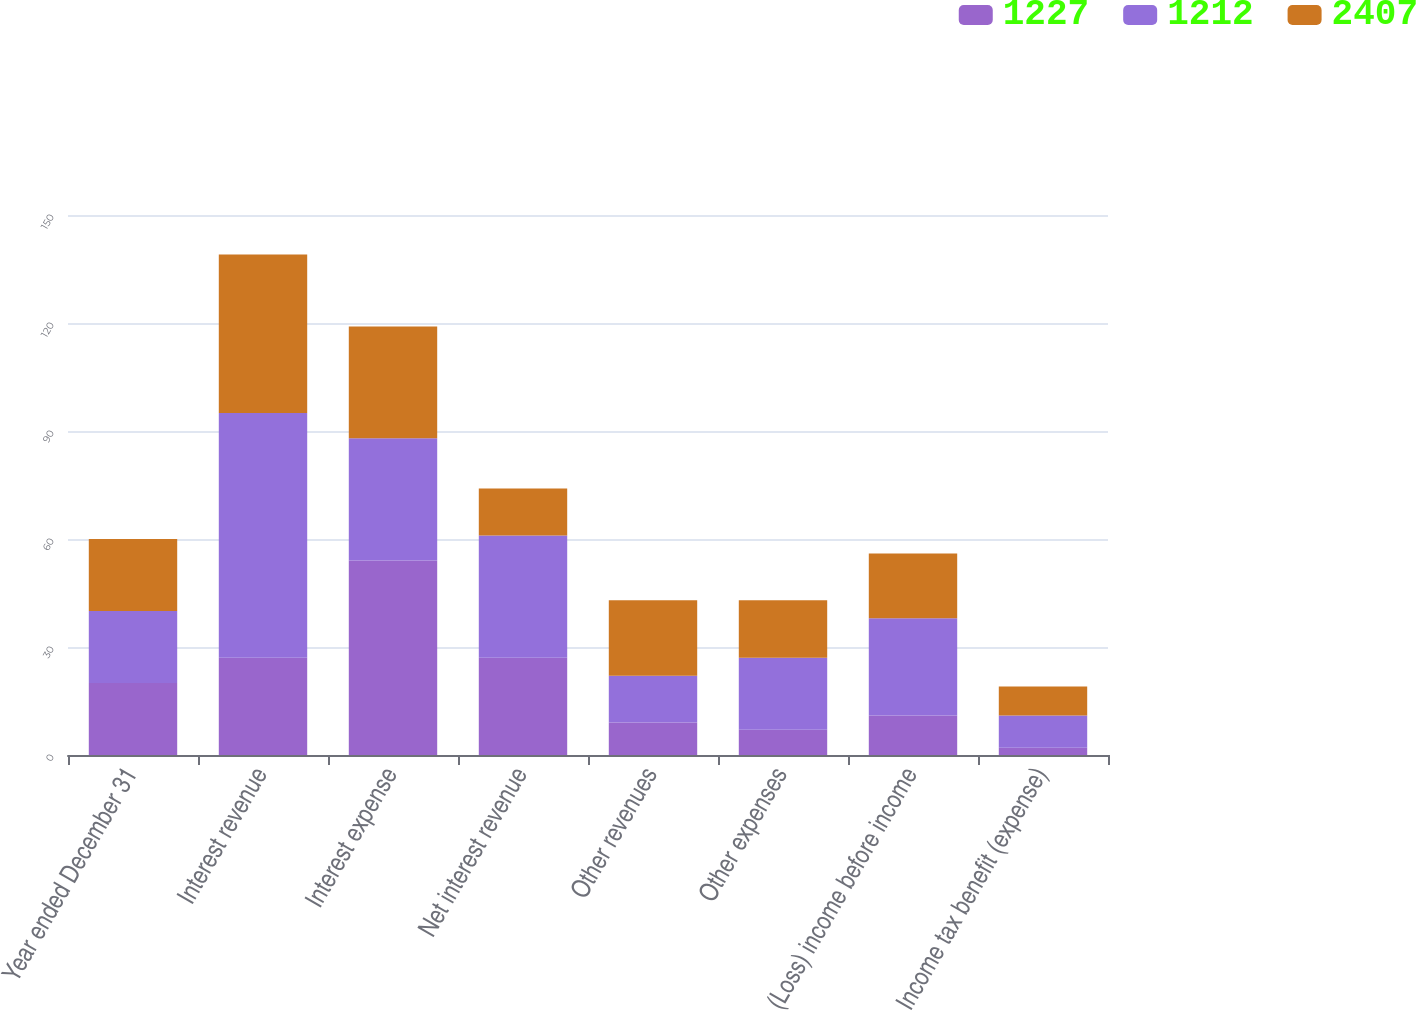<chart> <loc_0><loc_0><loc_500><loc_500><stacked_bar_chart><ecel><fcel>Year ended December 31<fcel>Interest revenue<fcel>Interest expense<fcel>Net interest revenue<fcel>Other revenues<fcel>Other expenses<fcel>(Loss) income before income<fcel>Income tax benefit (expense)<nl><fcel>1227<fcel>20<fcel>27<fcel>54<fcel>27<fcel>9<fcel>7<fcel>11<fcel>2<nl><fcel>1212<fcel>20<fcel>68<fcel>34<fcel>34<fcel>13<fcel>20<fcel>27<fcel>9<nl><fcel>2407<fcel>20<fcel>44<fcel>31<fcel>13<fcel>21<fcel>16<fcel>18<fcel>8<nl></chart> 